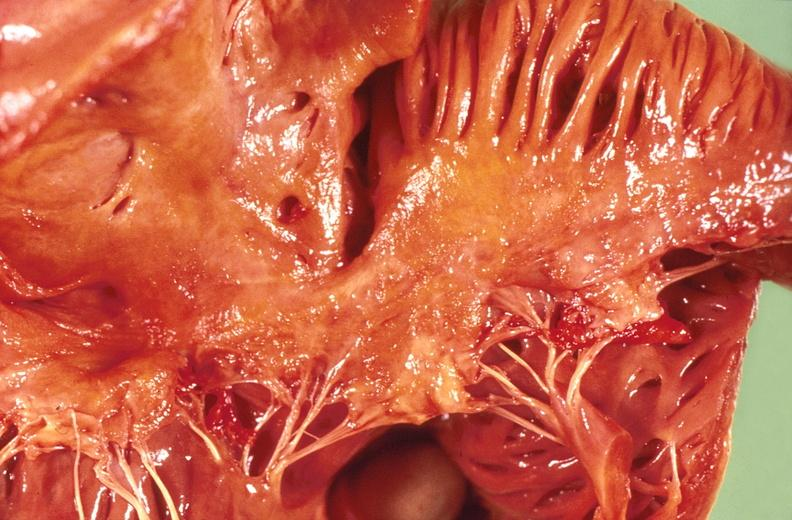what is present?
Answer the question using a single word or phrase. Cardiovascular 